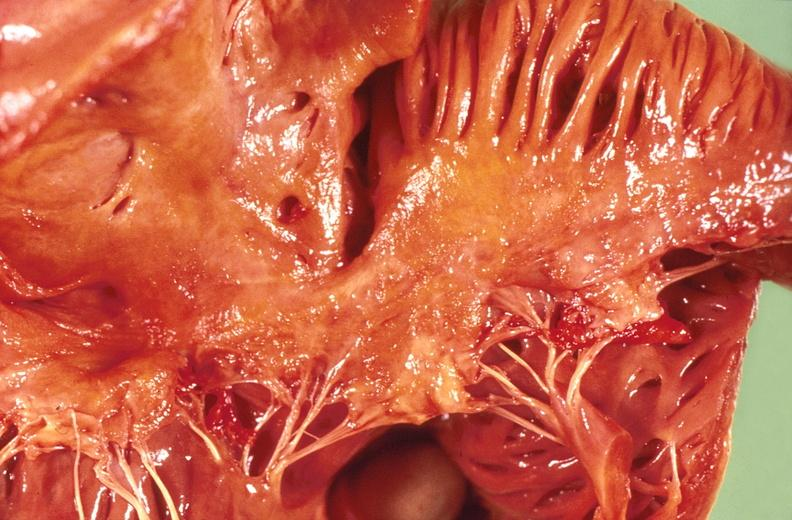what is present?
Answer the question using a single word or phrase. Cardiovascular 